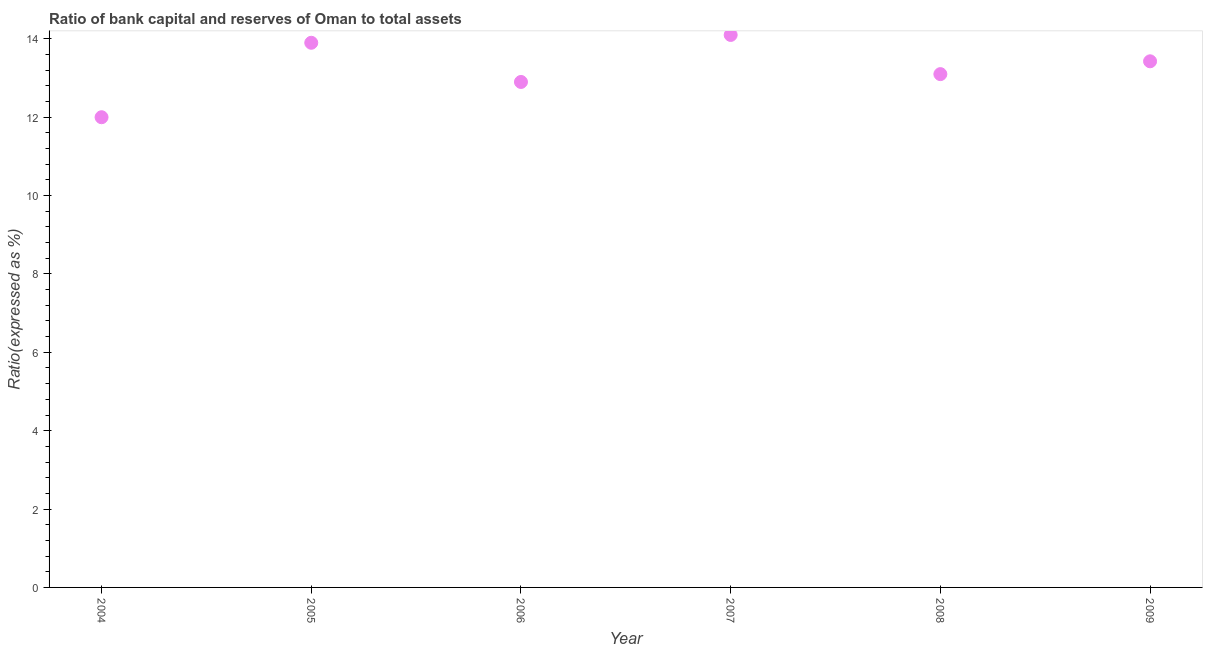What is the sum of the bank capital to assets ratio?
Ensure brevity in your answer.  79.43. What is the average bank capital to assets ratio per year?
Provide a short and direct response. 13.24. What is the median bank capital to assets ratio?
Ensure brevity in your answer.  13.26. Do a majority of the years between 2009 and 2006 (inclusive) have bank capital to assets ratio greater than 12 %?
Give a very brief answer. Yes. What is the ratio of the bank capital to assets ratio in 2007 to that in 2008?
Provide a short and direct response. 1.08. What is the difference between the highest and the second highest bank capital to assets ratio?
Provide a short and direct response. 0.2. Is the sum of the bank capital to assets ratio in 2004 and 2005 greater than the maximum bank capital to assets ratio across all years?
Make the answer very short. Yes. What is the difference between the highest and the lowest bank capital to assets ratio?
Your answer should be very brief. 2.1. In how many years, is the bank capital to assets ratio greater than the average bank capital to assets ratio taken over all years?
Provide a succinct answer. 3. Does the bank capital to assets ratio monotonically increase over the years?
Provide a short and direct response. No. How many years are there in the graph?
Provide a succinct answer. 6. What is the difference between two consecutive major ticks on the Y-axis?
Provide a succinct answer. 2. Are the values on the major ticks of Y-axis written in scientific E-notation?
Provide a succinct answer. No. Does the graph contain any zero values?
Offer a terse response. No. Does the graph contain grids?
Give a very brief answer. No. What is the title of the graph?
Provide a short and direct response. Ratio of bank capital and reserves of Oman to total assets. What is the label or title of the Y-axis?
Offer a very short reply. Ratio(expressed as %). What is the Ratio(expressed as %) in 2004?
Offer a very short reply. 12. What is the Ratio(expressed as %) in 2007?
Your response must be concise. 14.1. What is the Ratio(expressed as %) in 2009?
Offer a very short reply. 13.43. What is the difference between the Ratio(expressed as %) in 2004 and 2007?
Your response must be concise. -2.1. What is the difference between the Ratio(expressed as %) in 2004 and 2009?
Provide a short and direct response. -1.43. What is the difference between the Ratio(expressed as %) in 2005 and 2006?
Your answer should be very brief. 1. What is the difference between the Ratio(expressed as %) in 2005 and 2007?
Offer a very short reply. -0.2. What is the difference between the Ratio(expressed as %) in 2005 and 2008?
Make the answer very short. 0.8. What is the difference between the Ratio(expressed as %) in 2005 and 2009?
Provide a succinct answer. 0.47. What is the difference between the Ratio(expressed as %) in 2006 and 2008?
Ensure brevity in your answer.  -0.2. What is the difference between the Ratio(expressed as %) in 2006 and 2009?
Provide a short and direct response. -0.53. What is the difference between the Ratio(expressed as %) in 2007 and 2009?
Provide a short and direct response. 0.67. What is the difference between the Ratio(expressed as %) in 2008 and 2009?
Make the answer very short. -0.33. What is the ratio of the Ratio(expressed as %) in 2004 to that in 2005?
Offer a very short reply. 0.86. What is the ratio of the Ratio(expressed as %) in 2004 to that in 2007?
Make the answer very short. 0.85. What is the ratio of the Ratio(expressed as %) in 2004 to that in 2008?
Give a very brief answer. 0.92. What is the ratio of the Ratio(expressed as %) in 2004 to that in 2009?
Offer a very short reply. 0.89. What is the ratio of the Ratio(expressed as %) in 2005 to that in 2006?
Provide a succinct answer. 1.08. What is the ratio of the Ratio(expressed as %) in 2005 to that in 2008?
Provide a succinct answer. 1.06. What is the ratio of the Ratio(expressed as %) in 2005 to that in 2009?
Give a very brief answer. 1.03. What is the ratio of the Ratio(expressed as %) in 2006 to that in 2007?
Offer a very short reply. 0.92. What is the ratio of the Ratio(expressed as %) in 2007 to that in 2008?
Provide a succinct answer. 1.08. 